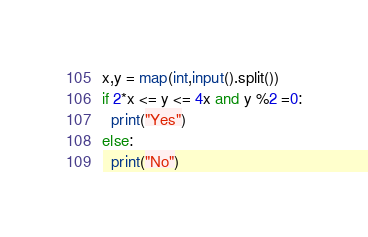Convert code to text. <code><loc_0><loc_0><loc_500><loc_500><_Python_>x,y = map(int,input().split())
if 2*x <= y <= 4x and y %2 =0:
  print("Yes")
else:
  print("No")</code> 